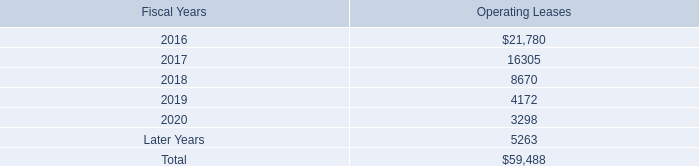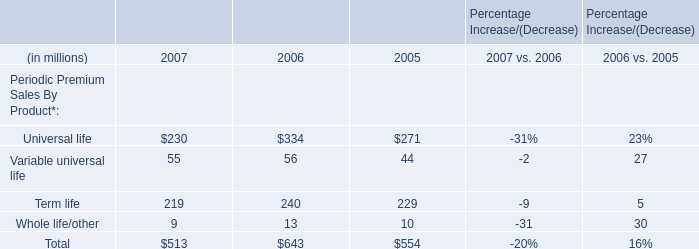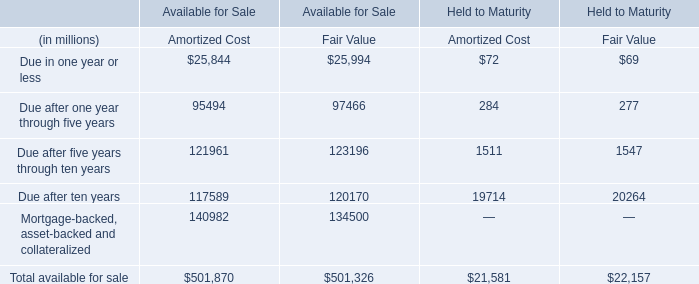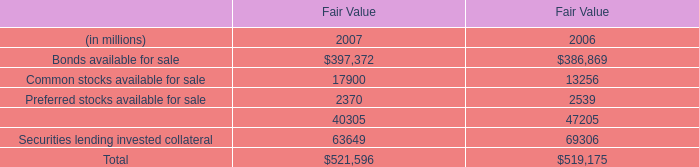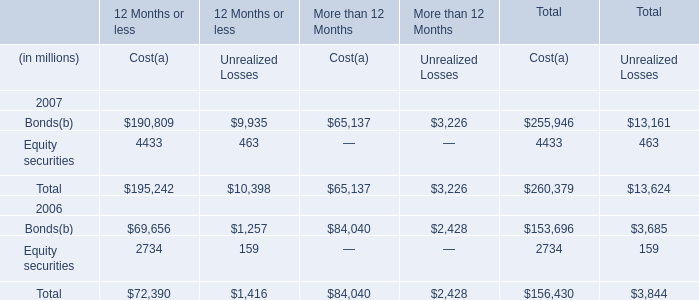What will Cost be like in 2008 if it develops with the same increasing rate as current? (in million) 
Computations: (260379 + ((260379 * (260379 - 156430)) / 156430))
Answer: 433402.9511. 